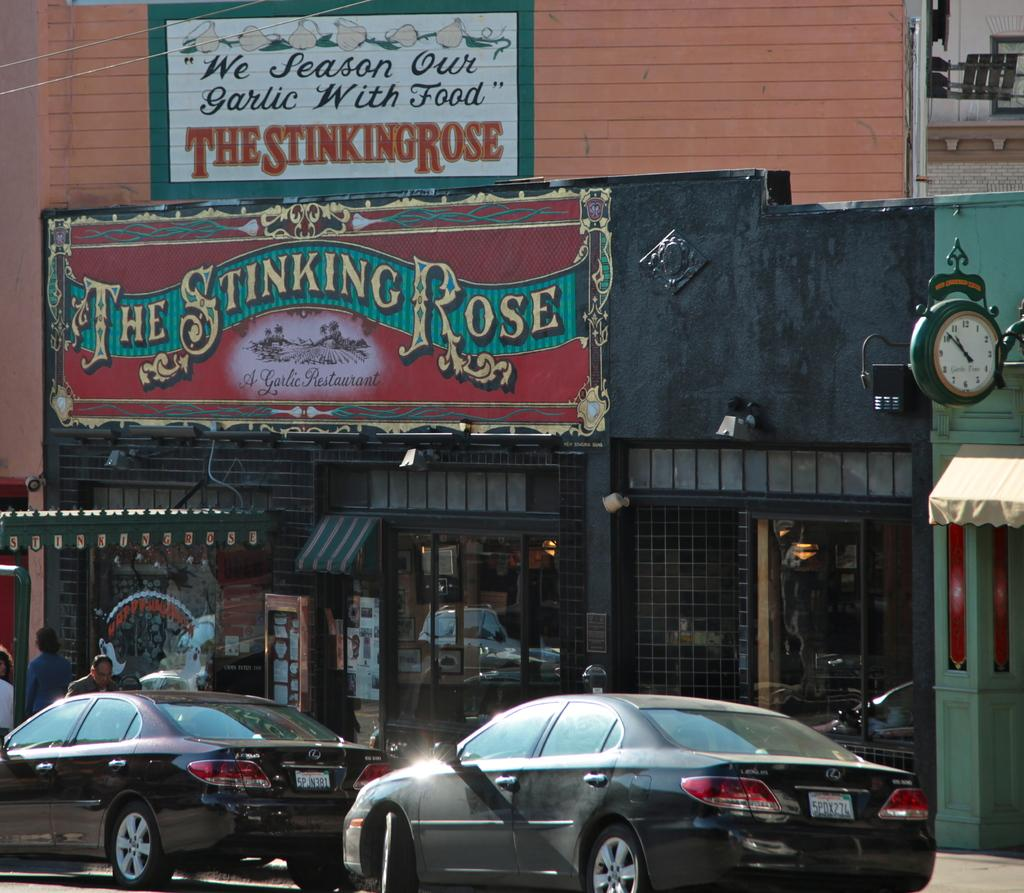What type of vehicles can be seen on the road in the image? There are cars on the road in the image. What structures are visible in the image? There are buildings in the image. What architectural feature is present in the image? There is a wall in the image. What time-related object is in the image? There is a clock in the image. What can be seen providing shade in the image? There is a sun shade in the image. Are there any living beings present in the image? Yes, there are people in the image. How many spiders are crawling on the buildings in the image? There are no spiders visible in the image; it only shows cars, buildings, a wall, a clock, a sun shade, and people. 